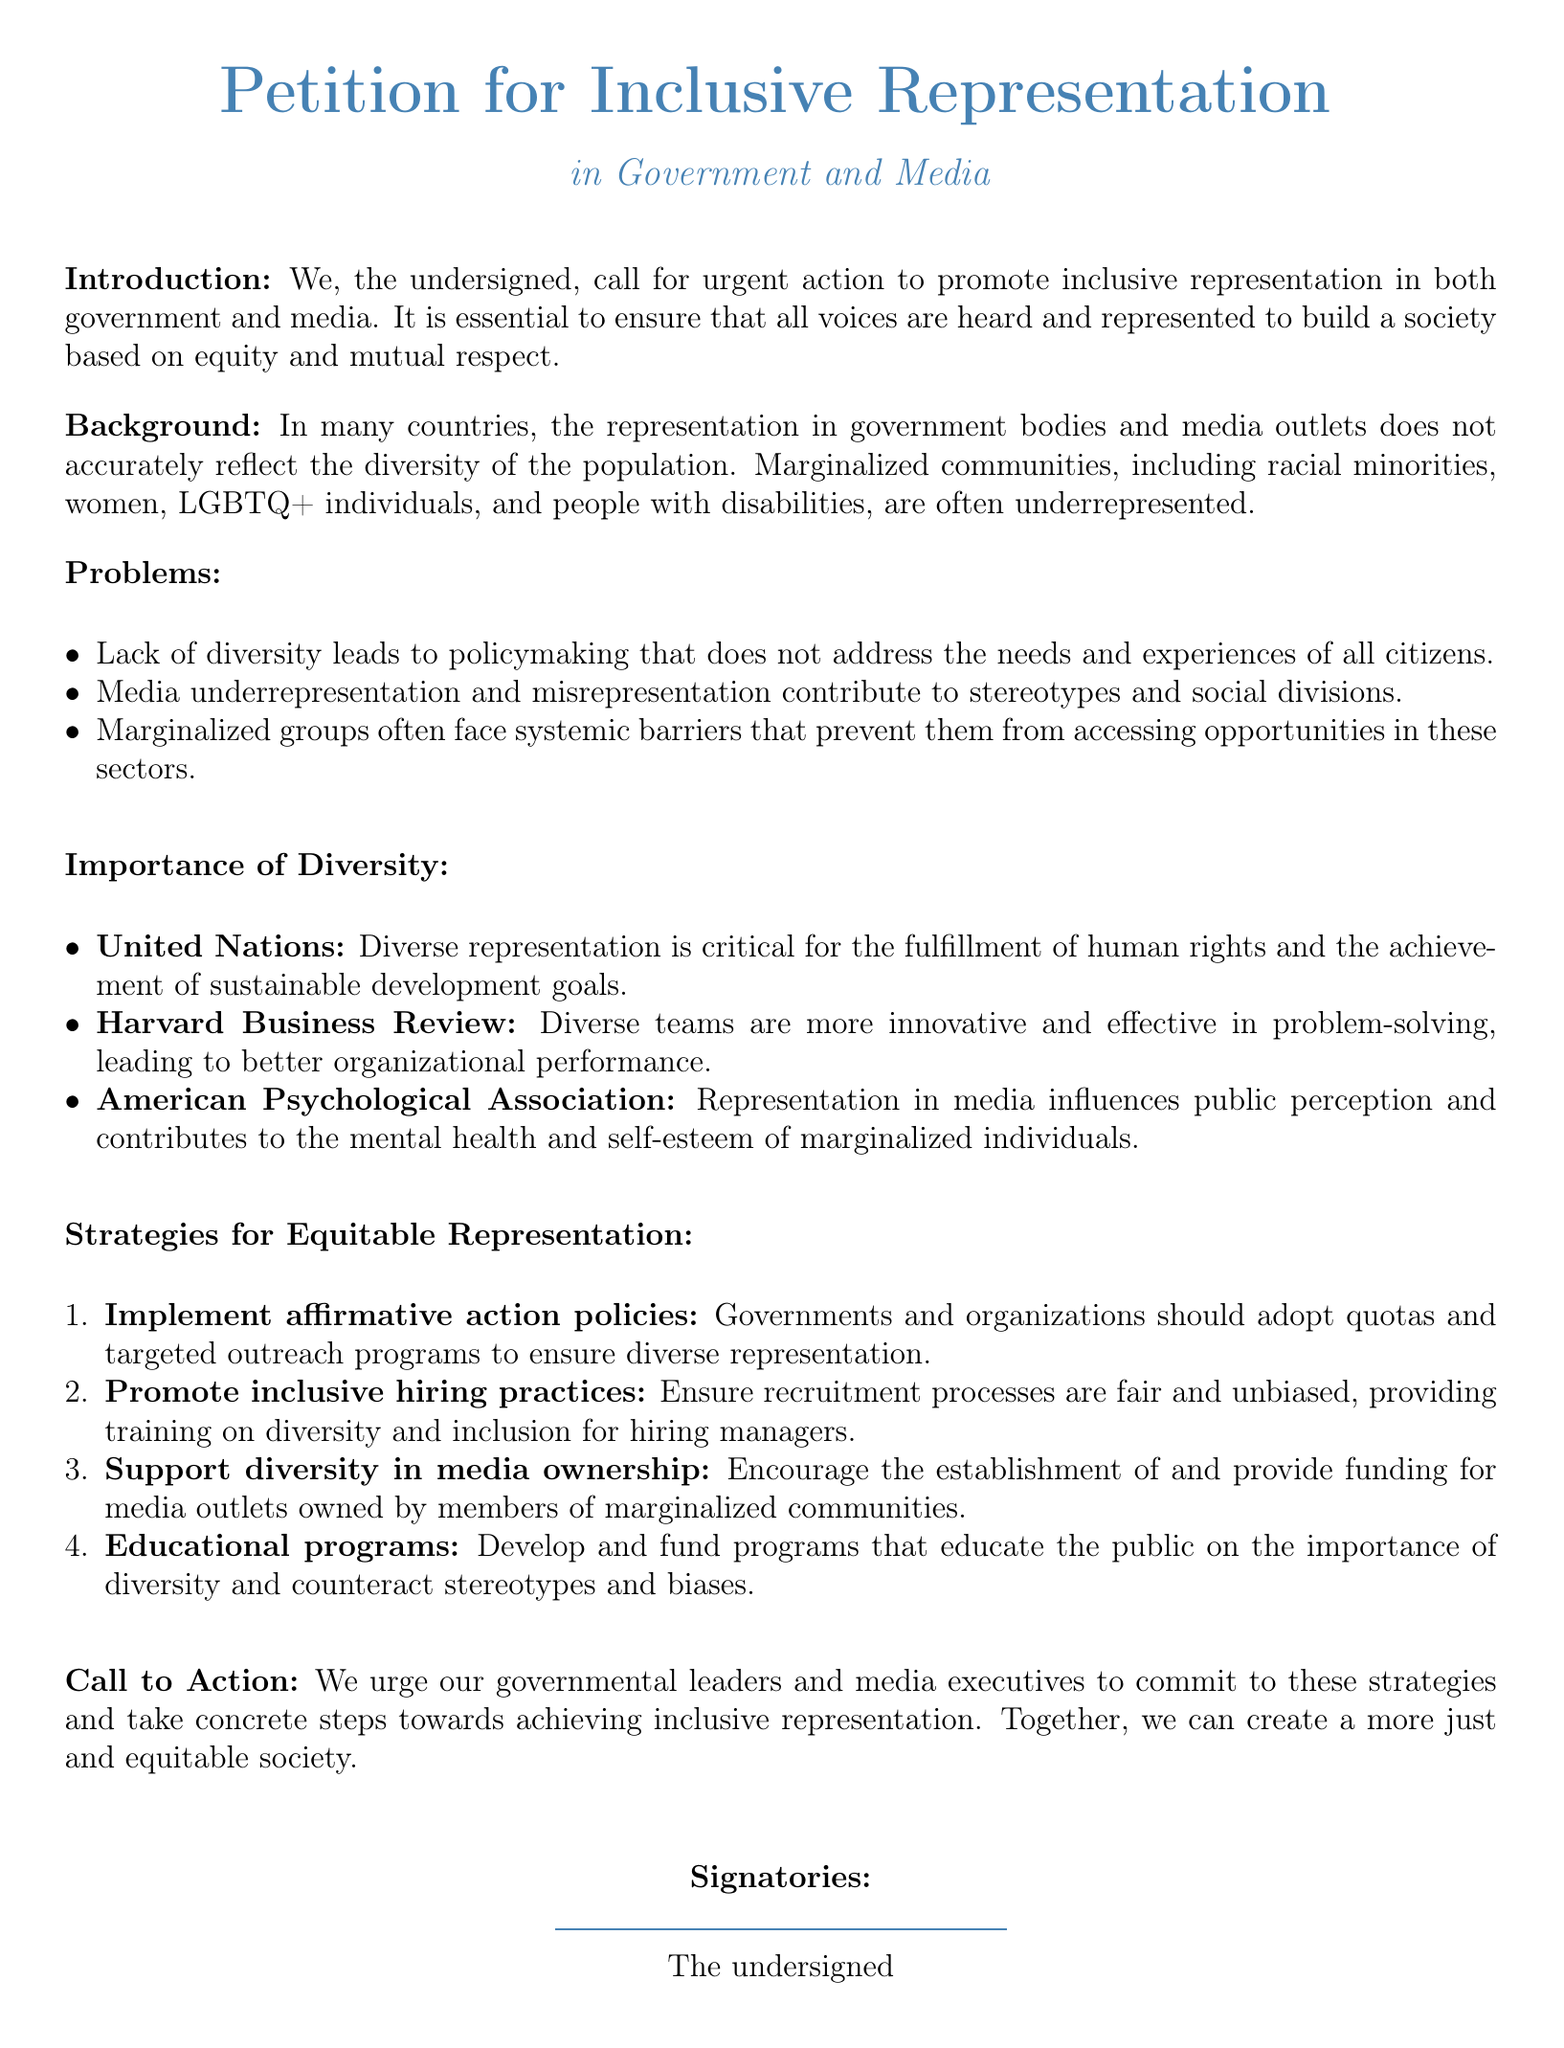what is the title of the petition? The title of the petition is explicitly stated at the beginning, which is "Petition for Inclusive Representation."
Answer: Petition for Inclusive Representation what is the main goal of the petition? The main goal is mentioned in the introduction, focusing on promoting inclusive representation in government and media.
Answer: Promote inclusive representation how many problems are listed in the document? The document lists three specific problems related to representation in government and media.
Answer: Three which organization is referenced in relation to the importance of diverse representation? The document mentions the United Nations in the section about the importance of diversity.
Answer: United Nations what is one strategy proposed for achieving equitable representation? One of the strategies proposed is implementing affirmative action policies.
Answer: Implement affirmative action policies how does the document suggest promoting inclusive hiring practices? The document states to ensure recruitment processes are fair and unbiased, providing training on diversity and inclusion.
Answer: Provide training on diversity and inclusion what are the signatories referred to in the document? The signatories are described as "The undersigned" at the end of the document.
Answer: The undersigned what type of communities does the petition highlight as underrepresented? The petition highlights marginalized communities, which include racial minorities, women, LGBTQ+ individuals, and people with disabilities.
Answer: Marginalized communities who is urged to commit to the strategies outlined in the petition? The petition urges governmental leaders and media executives to commit to these strategies.
Answer: Governmental leaders and media executives 